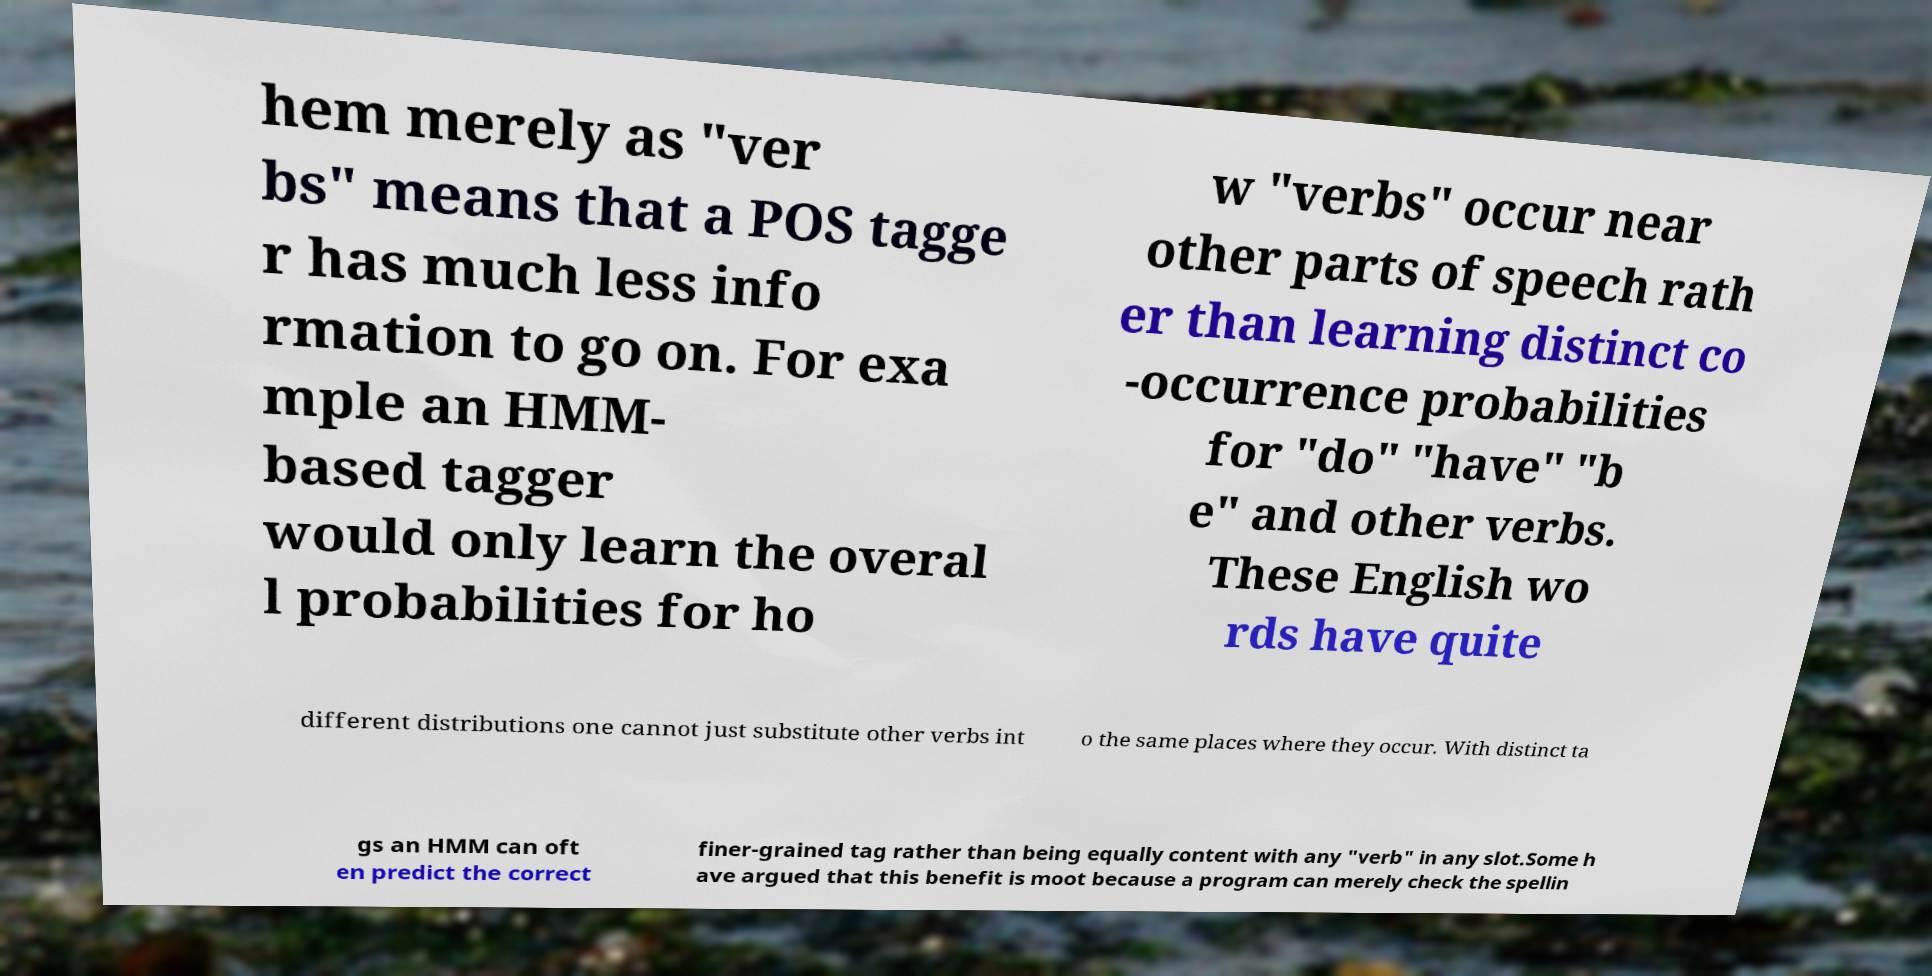Please identify and transcribe the text found in this image. hem merely as "ver bs" means that a POS tagge r has much less info rmation to go on. For exa mple an HMM- based tagger would only learn the overal l probabilities for ho w "verbs" occur near other parts of speech rath er than learning distinct co -occurrence probabilities for "do" "have" "b e" and other verbs. These English wo rds have quite different distributions one cannot just substitute other verbs int o the same places where they occur. With distinct ta gs an HMM can oft en predict the correct finer-grained tag rather than being equally content with any "verb" in any slot.Some h ave argued that this benefit is moot because a program can merely check the spellin 